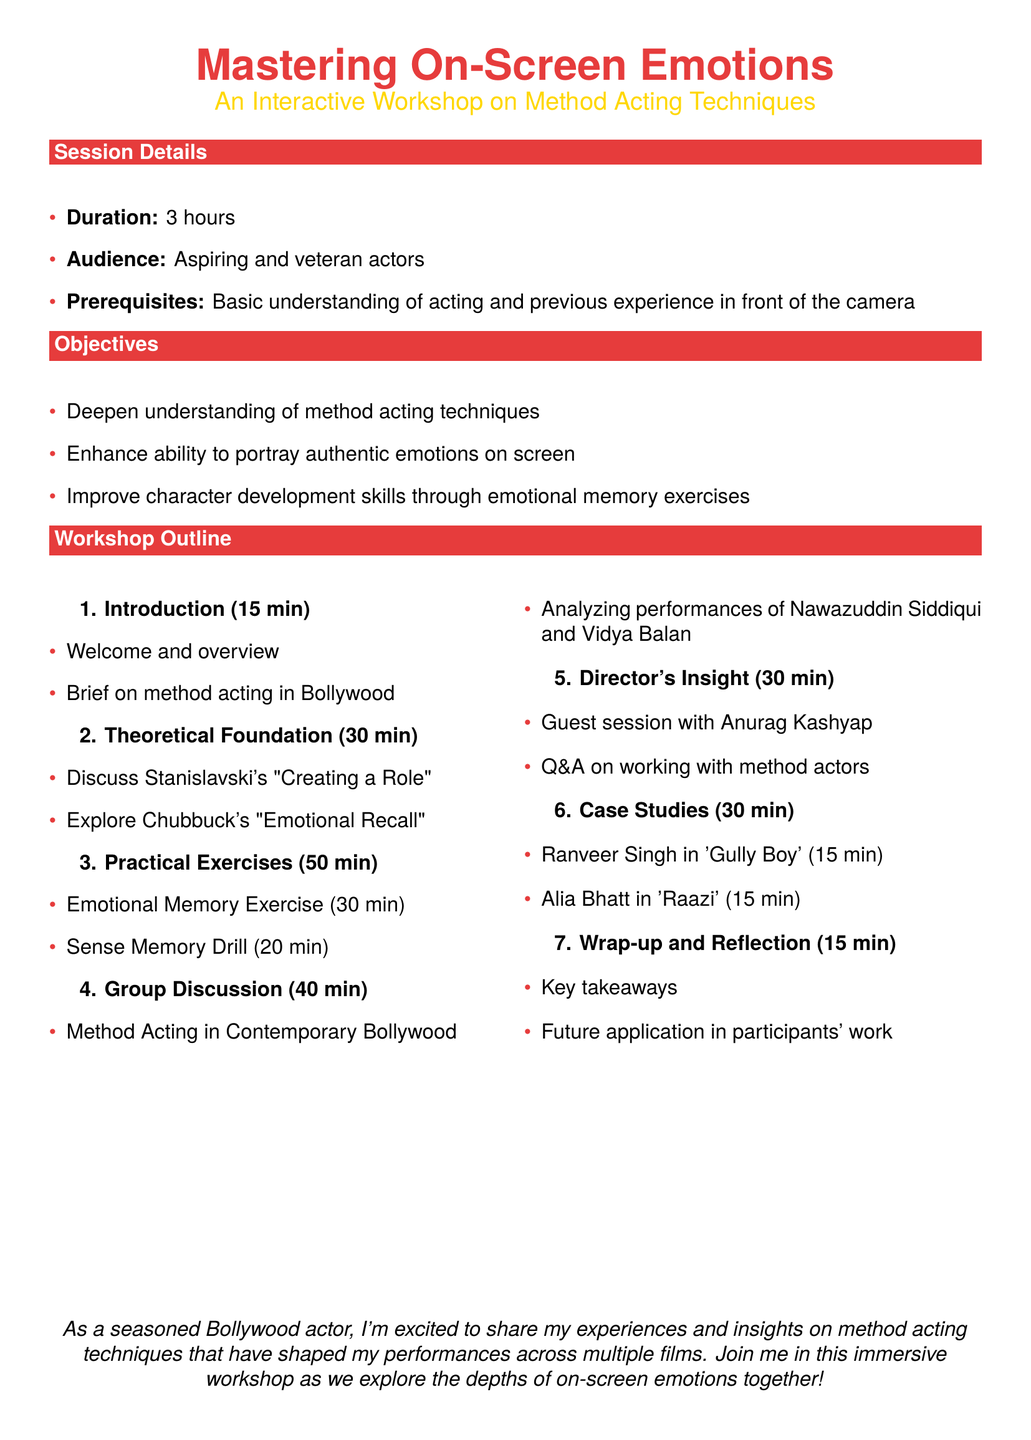What is the duration of the workshop? The duration of the workshop is specified in the session details as lasting three hours.
Answer: 3 hours Who is the guest speaker for the director's insight session? The guest speaker for the director's insight session is mentioned in the outline of the workshop.
Answer: Anurag Kashyap How long is the practical exercises section? The time allocated for practical exercises is detailed in the workshop outline, which sums to fifty minutes.
Answer: 50 min What is one of the objectives of the workshop? The objectives of the workshop highlight key intentions, such as enhancing the ability to portray authentic emotions on screen.
Answer: Enhance ability to portray authentic emotions on screen Which actors' performances are analyzed in the group discussion? The group discussion section specifically states which actors will be analyzed for their method acting.
Answer: Nawazuddin Siddiqui and Vidya Balan What is the total time allocated for case studies? The total time for case studies is presented by adding the time specified for each actor's case study in the workshop outline.
Answer: 30 min 